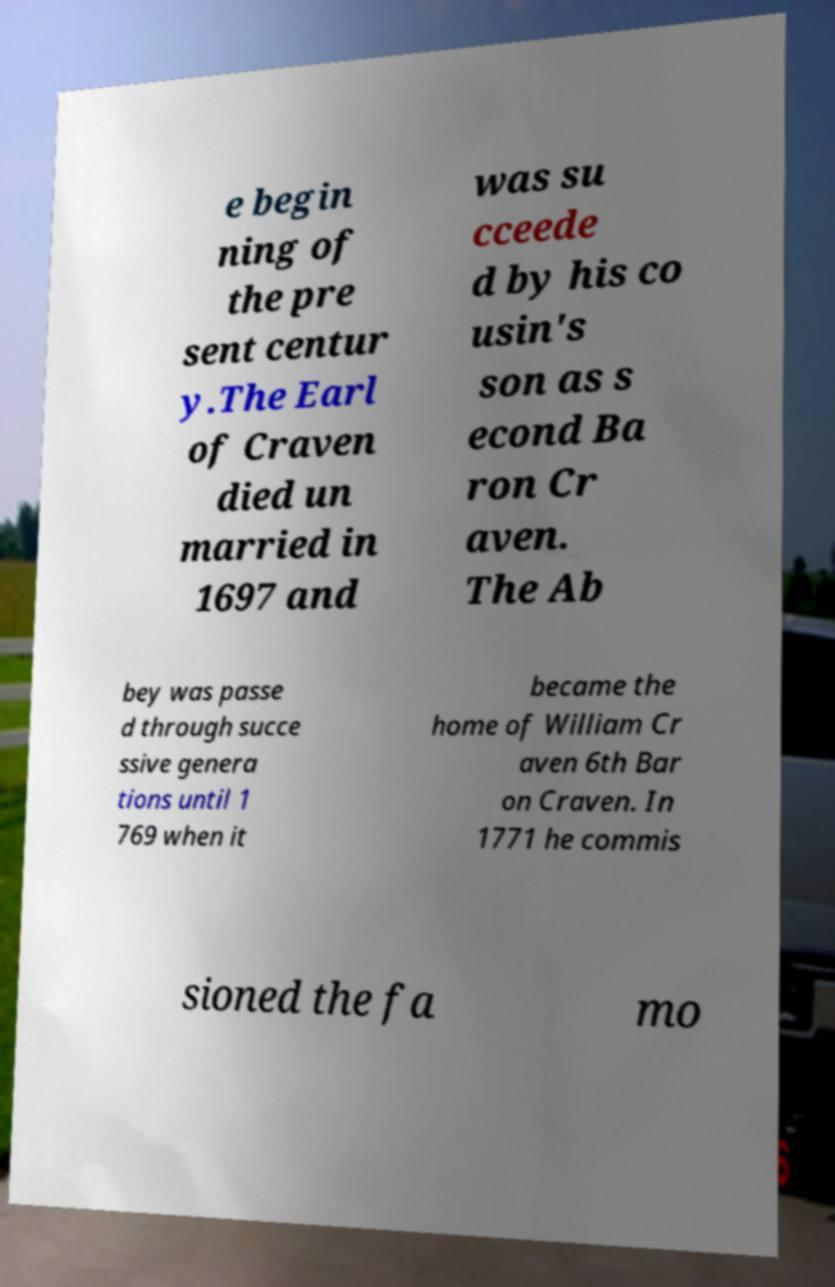Could you extract and type out the text from this image? e begin ning of the pre sent centur y.The Earl of Craven died un married in 1697 and was su cceede d by his co usin's son as s econd Ba ron Cr aven. The Ab bey was passe d through succe ssive genera tions until 1 769 when it became the home of William Cr aven 6th Bar on Craven. In 1771 he commis sioned the fa mo 